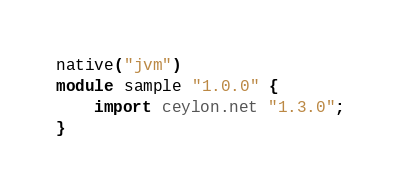<code> <loc_0><loc_0><loc_500><loc_500><_Ceylon_>native("jvm")
module sample "1.0.0" {
    import ceylon.net "1.3.0";
}
</code> 